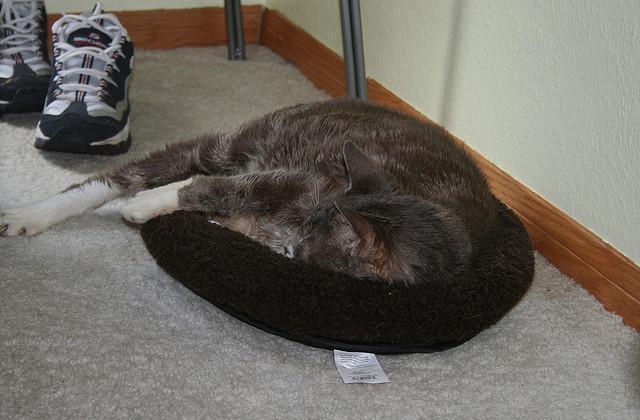How many cars have zebra stripes?
Give a very brief answer. 0. 